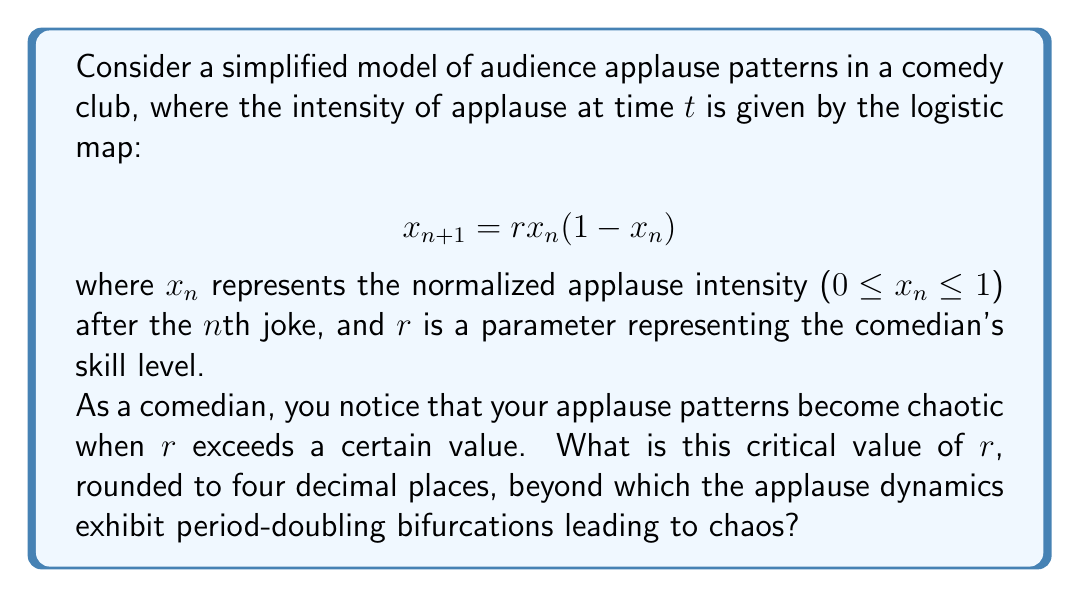What is the answer to this math problem? To find the critical value of $r$ where the applause dynamics become chaotic, we need to analyze the period-doubling bifurcations in the logistic map:

1. The logistic map undergoes a series of period-doubling bifurcations as $r$ increases.

2. These bifurcations occur at increasingly shorter intervals of $r$, converging to a limit known as the Feigenbaum constant.

3. The onset of chaos occurs at the accumulation point of these period-doubling bifurcations.

4. For the logistic map, this critical value is known as the Feigenbaum point.

5. The exact value of $r$ at the Feigenbaum point is approximately 3.56994567...

6. Rounding this value to four decimal places gives us 3.5699.

Beyond this value of $r$, the applause dynamics will exhibit chaotic behavior, meaning that small changes in initial conditions can lead to vastly different outcomes, making the audience response unpredictable and sensitive to subtle variations in your performance.
Answer: 3.5699 